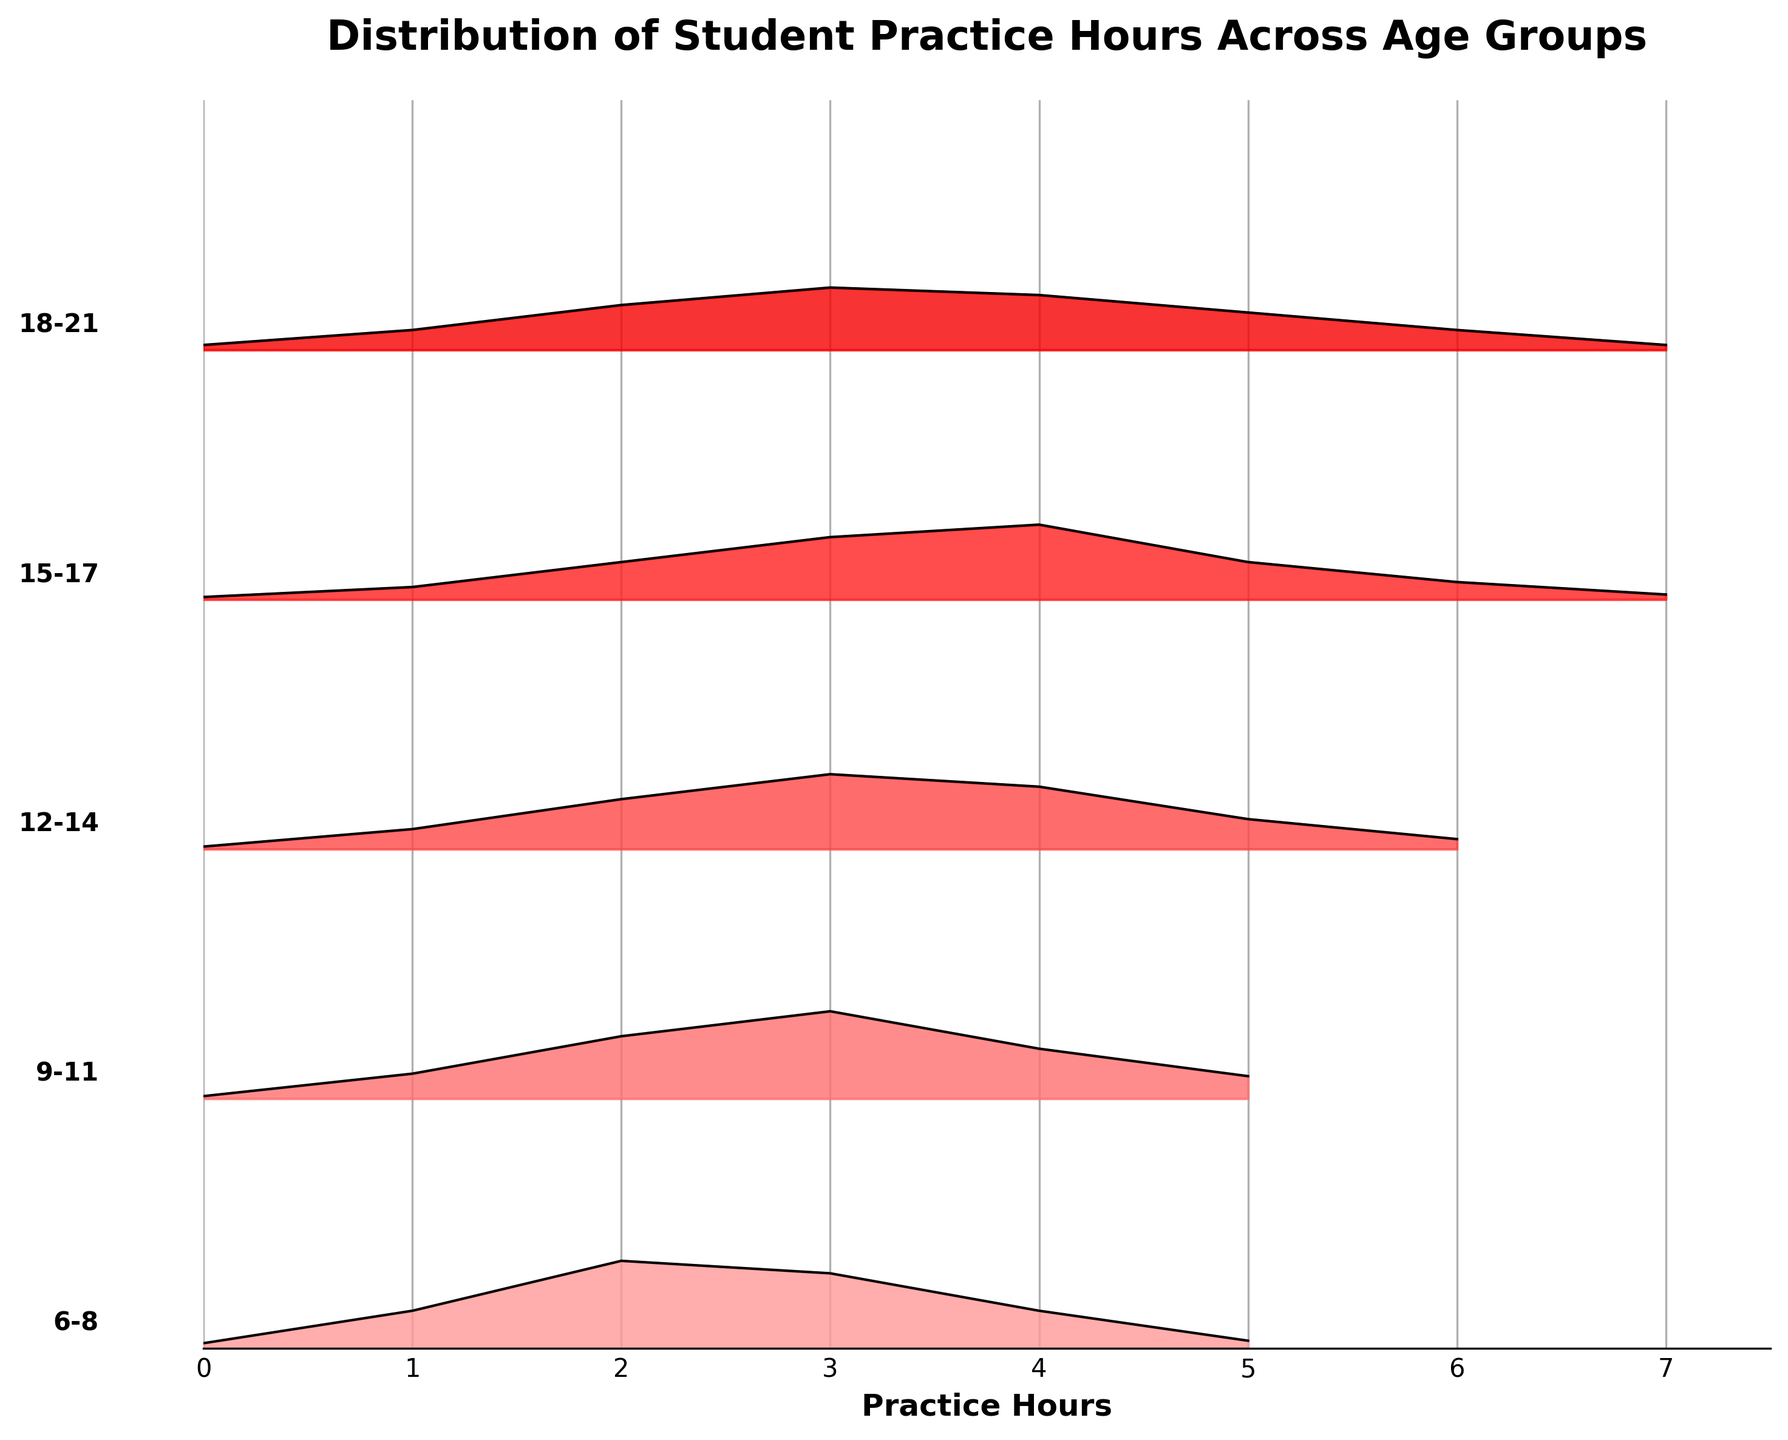What is the title of the figure? The title of the figure is typically written at the top of the plot and summarizes the main focus of the data presentation. It is visible in large, bold text.
Answer: Distribution of Student Practice Hours Across Age Groups What does the x-axis represent in this plot? The label on the x-axis provides information about what the horizontal axis measures. Based on the figure, we can see that it is labeled clearly.
Answer: Practice Hours Which age group has the most pronounced peak in practice hours? By looking for the highest peak across all ridgelines, we can determine which age group has the greatest concentration of practice hours.
Answer: 9-11 How do the practice hours of students aged 15-17 compare to those aged 6-8? By examining the shape and height of the ridgelines, we can see the distribution pattern of practice hours for both groups to identify differences and similarities.
Answer: Students aged 15-17 tend to practice more hours, as their peak is at 4 hours compared to the peak of 2 hours for students aged 6-8 What range of practice hours is most common for students aged 18-21? We need to observe the range of hours where the density is highest for the 18-21 age group ridgeline.
Answer: 3-4 hours Among all age groups, which one shows the widest distribution of practice hours? Identifying which age group ridgeline is spread across the most number of practice hours indicates the widest distribution.
Answer: 18-21 For which age group is practicing 2 hours less common compared to other hours? By looking closely at the ridgelines and their densities at the 2-hour mark, we can see which age group has a lower density at that point.
Answer: 15-17 Is there any age group that shows a significant practice duration of 6 hours or more? By observing the right-end of the ridgelines, we can identify if any age groups have noticeable densities beyond 6 hours.
Answer: 15-17 and 18-21 Compare the practice hours for the age groups 12-14 and 15-17, which age group has a more consistent practice routine? Observing the smoothness and peak consistency of the ridgelines will help us understand the steadiness in practice routines for each age group.
Answer: 12-14, as their ridgeline is more evenly distributed At what practice hour does the density begin to decline for the 9-11 age group? Finding the peak and then observing where the ridgeline density decreases will show the practice hour at which density begins to decline.
Answer: 3 hours 